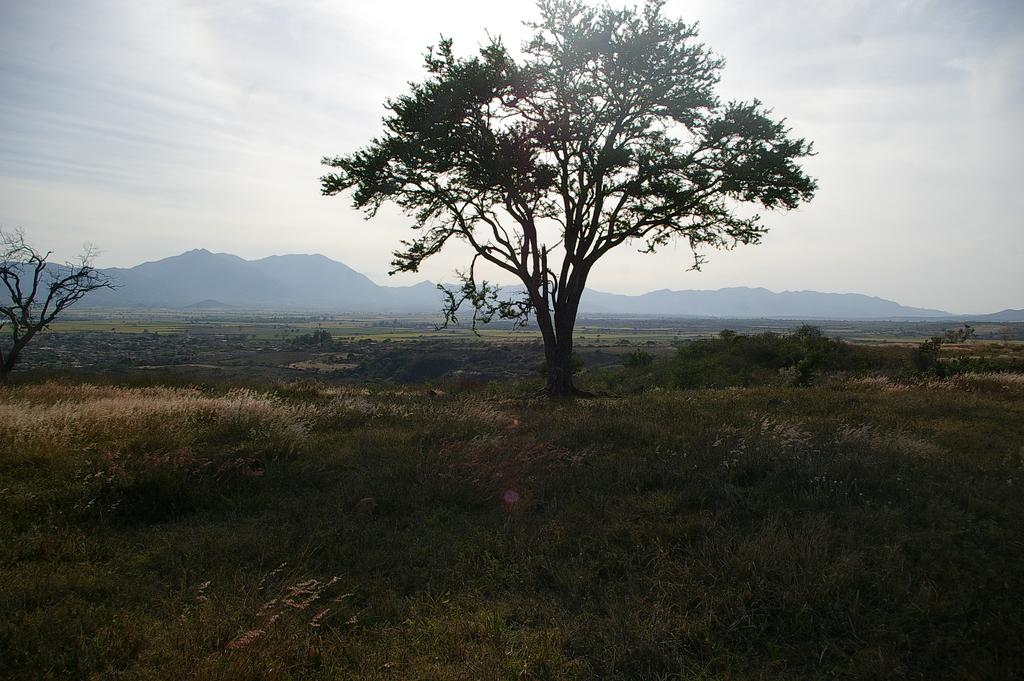What type of vegetation can be seen in the image? There are trees, plants, and grass visible in the image. What is the landscape like in the image? The landscape includes trees, plants, grass, and mountains in the background. What can be seen in the sky in the image? The sky is visible in the background of the image. How many cups can be seen on the grass in the image? There are no cups present in the image; it features trees, plants, grass, mountains, and the sky. Can you tell me how fast the plants are running in the image? Plants do not have the ability to run, so this question cannot be answered. 